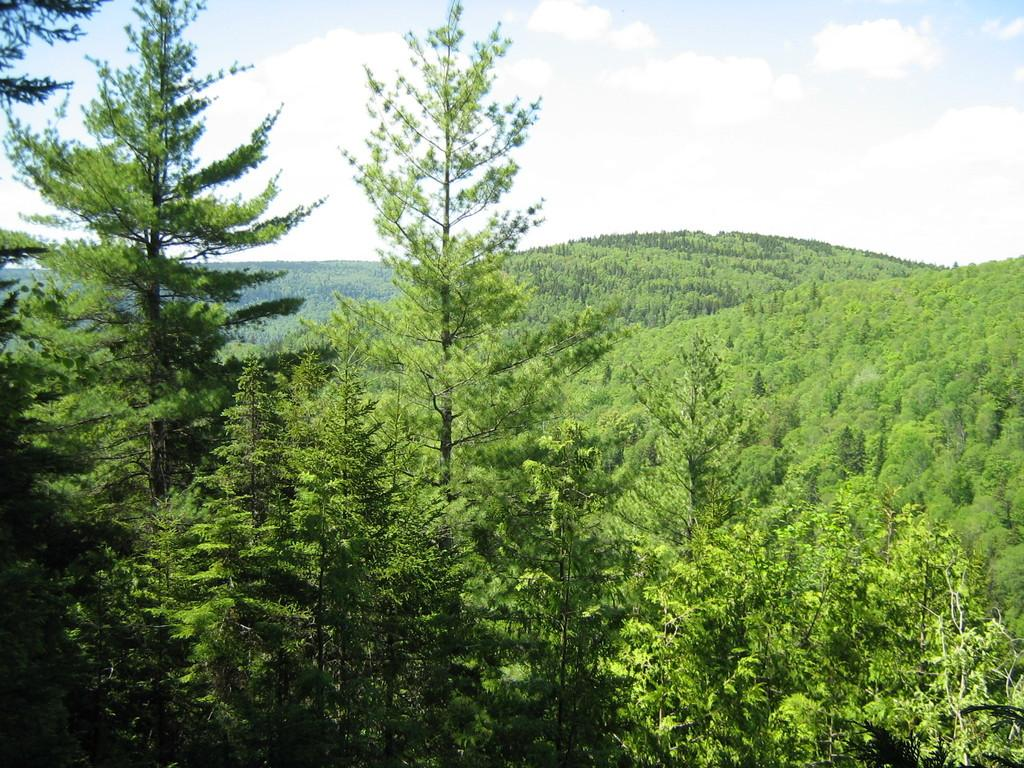What type of vegetation can be seen in the image? There are trees in the image. What can be seen in the background of the image? There are hills with trees in the background. What is visible at the top of the image? The sky is visible at the top of the image. What can be observed in the sky? Clouds are present in the sky. Where is the grandmother standing in the image? There is no grandmother present in the image. What type of dolls can be seen playing in the alley in the image? There are no dolls or alley present in the image. 